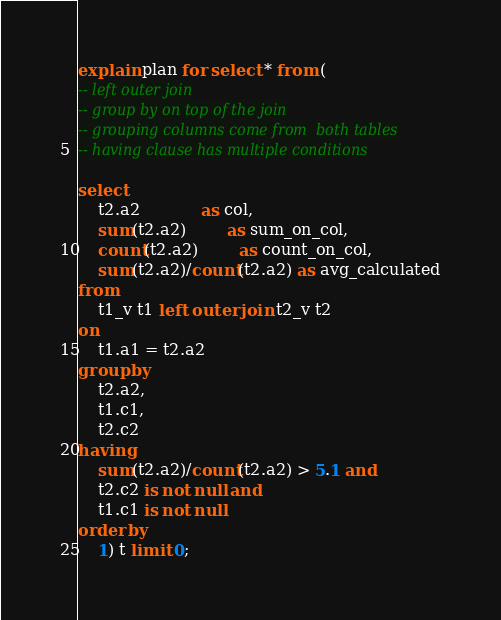<code> <loc_0><loc_0><loc_500><loc_500><_SQL_>explain plan for select * from (
-- left outer join
-- group by on top of the join
-- grouping columns come from  both tables
-- having clause has multiple conditions

select 
	t2.a2			as col,
	sum(t2.a2)		as sum_on_col,
	count(t2.a2)		as count_on_col,
	sum(t2.a2)/count(t2.a2) as avg_calculated
from
	t1_v t1 left outer join t2_v t2
on 
	t1.a1 = t2.a2 
group by
	t2.a2,
	t1.c1,
	t2.c2
having
	sum(t2.a2)/count(t2.a2) > 5.1 and
	t2.c2 is not null and
	t1.c1 is not null
order by
	1) t limit 0;
</code> 